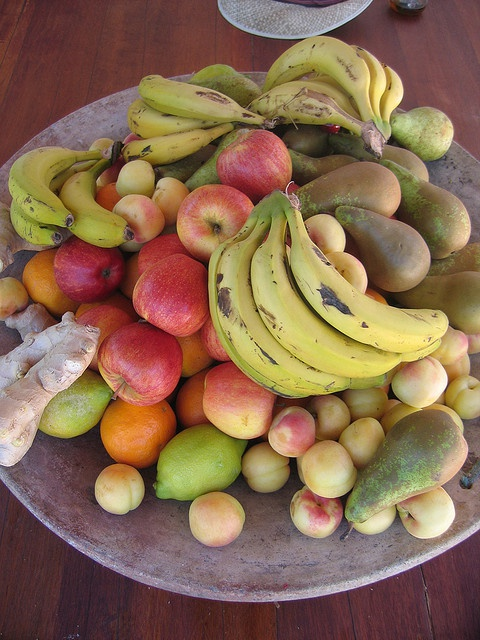Describe the objects in this image and their specific colors. I can see banana in maroon, khaki, and tan tones, apple in maroon, tan, brown, and gray tones, banana in maroon, tan, olive, gray, and khaki tones, banana in maroon and olive tones, and apple in maroon, brown, salmon, and tan tones in this image. 